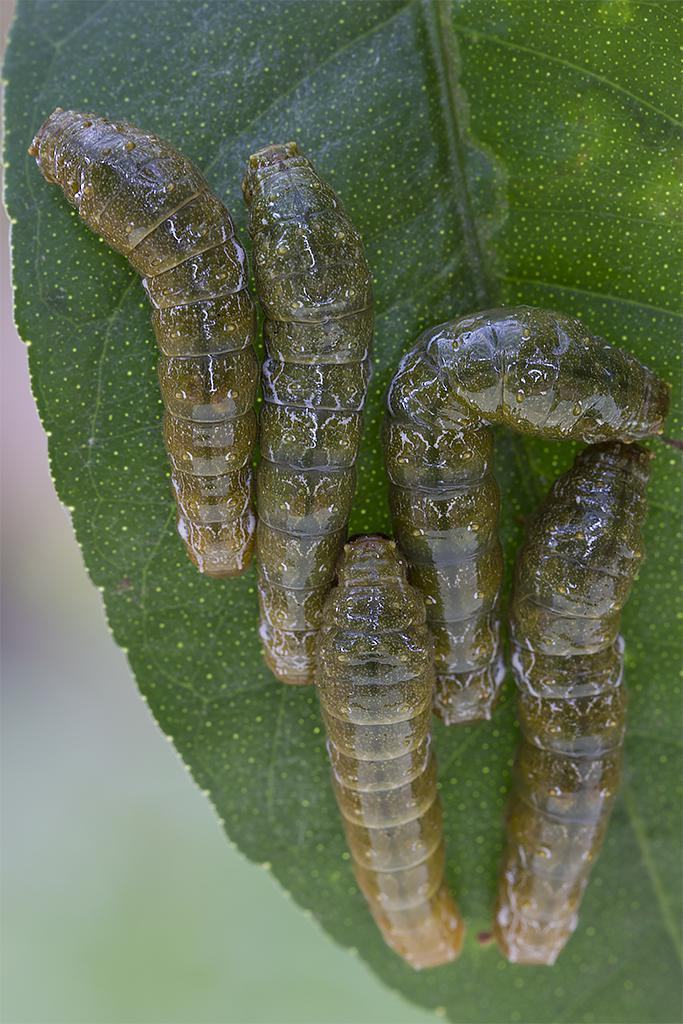What type of insects are present on the leaf in the image? There are caterpillars on a leaf in the image. Can you describe the background of the image? The background of the image is blurred. How many holes can be seen in the pan in the image? There is no pan present in the image, so it is not possible to determine the number of holes. 